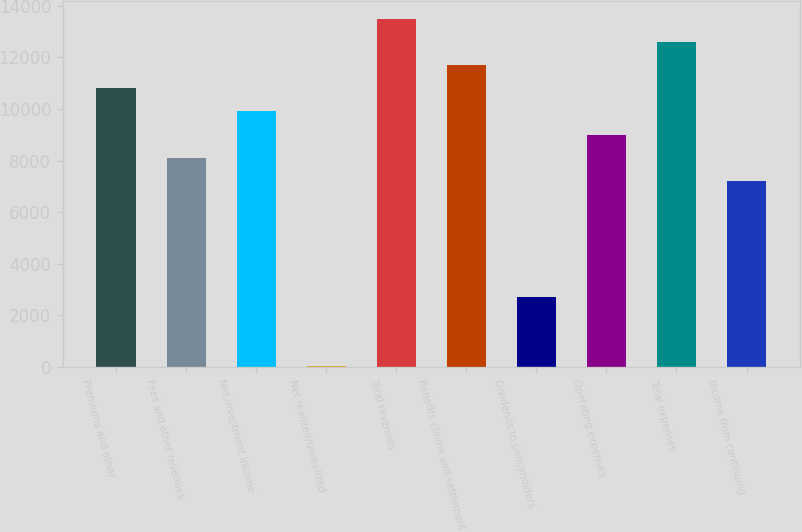Convert chart. <chart><loc_0><loc_0><loc_500><loc_500><bar_chart><fcel>Premiums and other<fcel>Fees and other revenues<fcel>Net investment income<fcel>Net realized/unrealized<fcel>Total revenues<fcel>Benefits claims and settlement<fcel>Dividends to policyholders<fcel>Operating expenses<fcel>Total expenses<fcel>Income from continuing<nl><fcel>10807<fcel>8108.05<fcel>9907.35<fcel>11.2<fcel>13506<fcel>11706.6<fcel>2710.15<fcel>9007.7<fcel>12606.3<fcel>7208.4<nl></chart> 